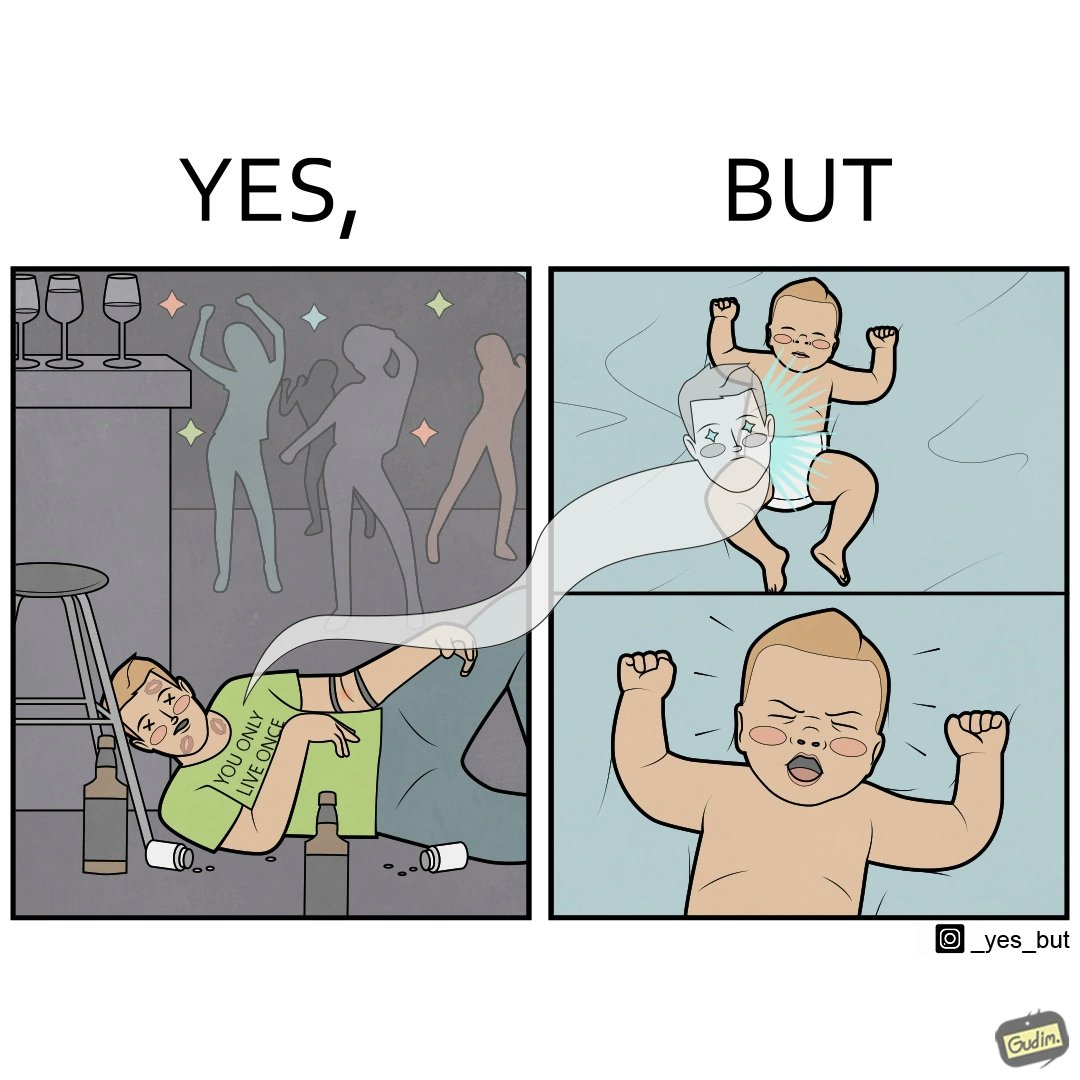Describe what you see in the left and right parts of this image. In the left part of the image: A person wearing a t-shirt that says "You Only Live Once" lying dead on the dance floor of a club probably due to drug overdose. In the right part of the image: A crying baby 